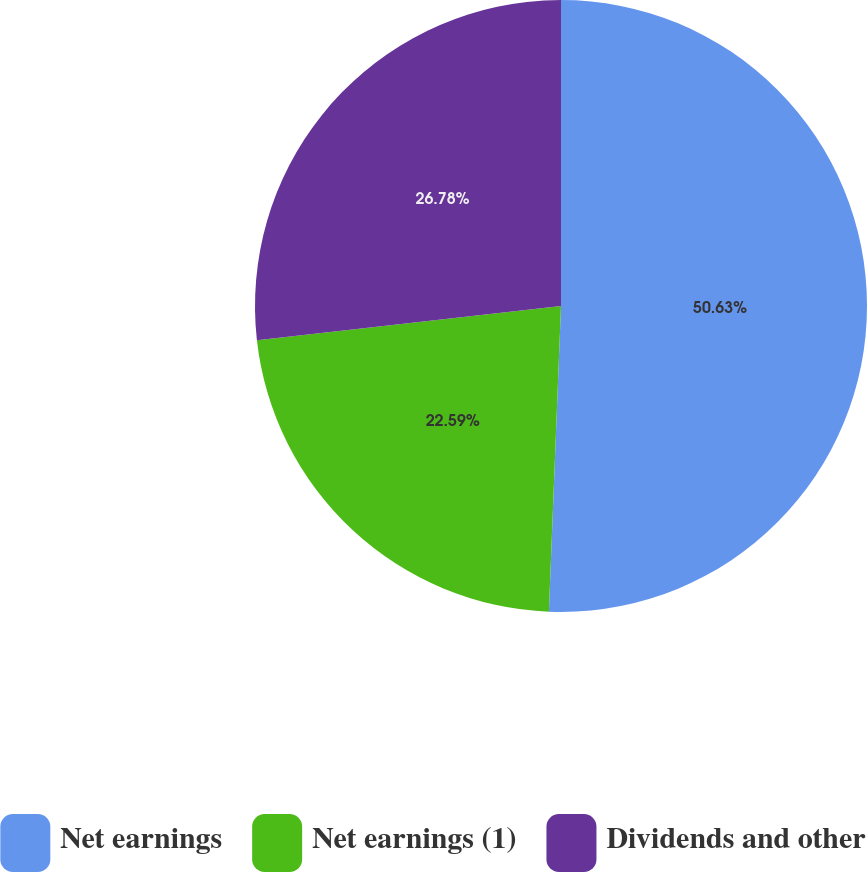<chart> <loc_0><loc_0><loc_500><loc_500><pie_chart><fcel>Net earnings<fcel>Net earnings (1)<fcel>Dividends and other<nl><fcel>50.63%<fcel>22.59%<fcel>26.78%<nl></chart> 